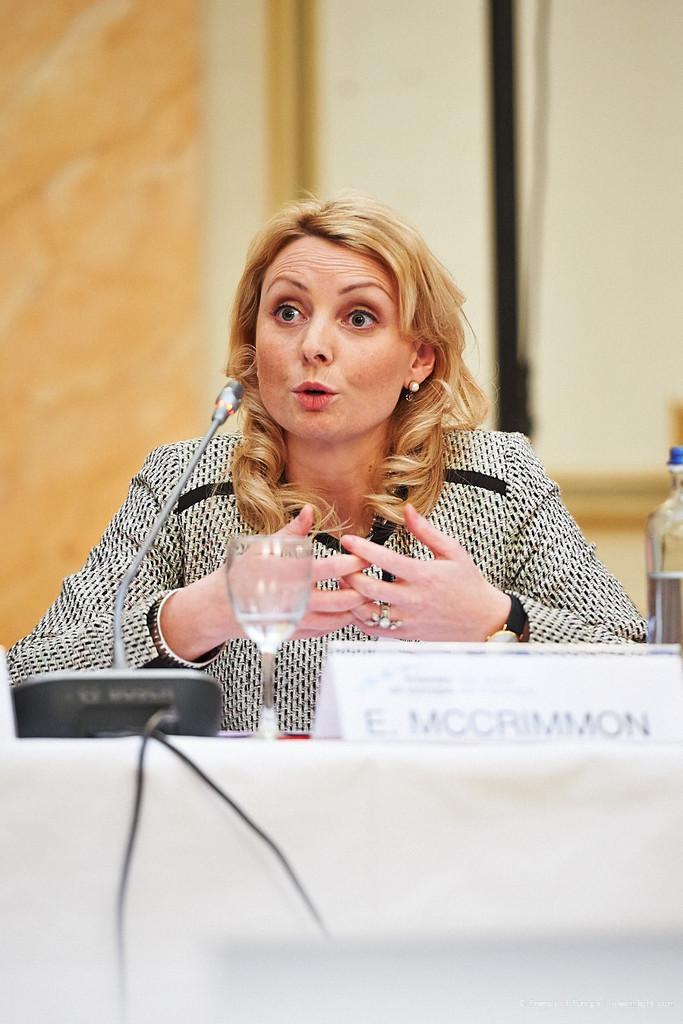How would you summarize this image in a sentence or two? In this picture I can see a woman seated and speaking with the help of a microphone and I can see a glass and a name board with some text and a bottle and a microphone on the table and looks like a wall in the back. 